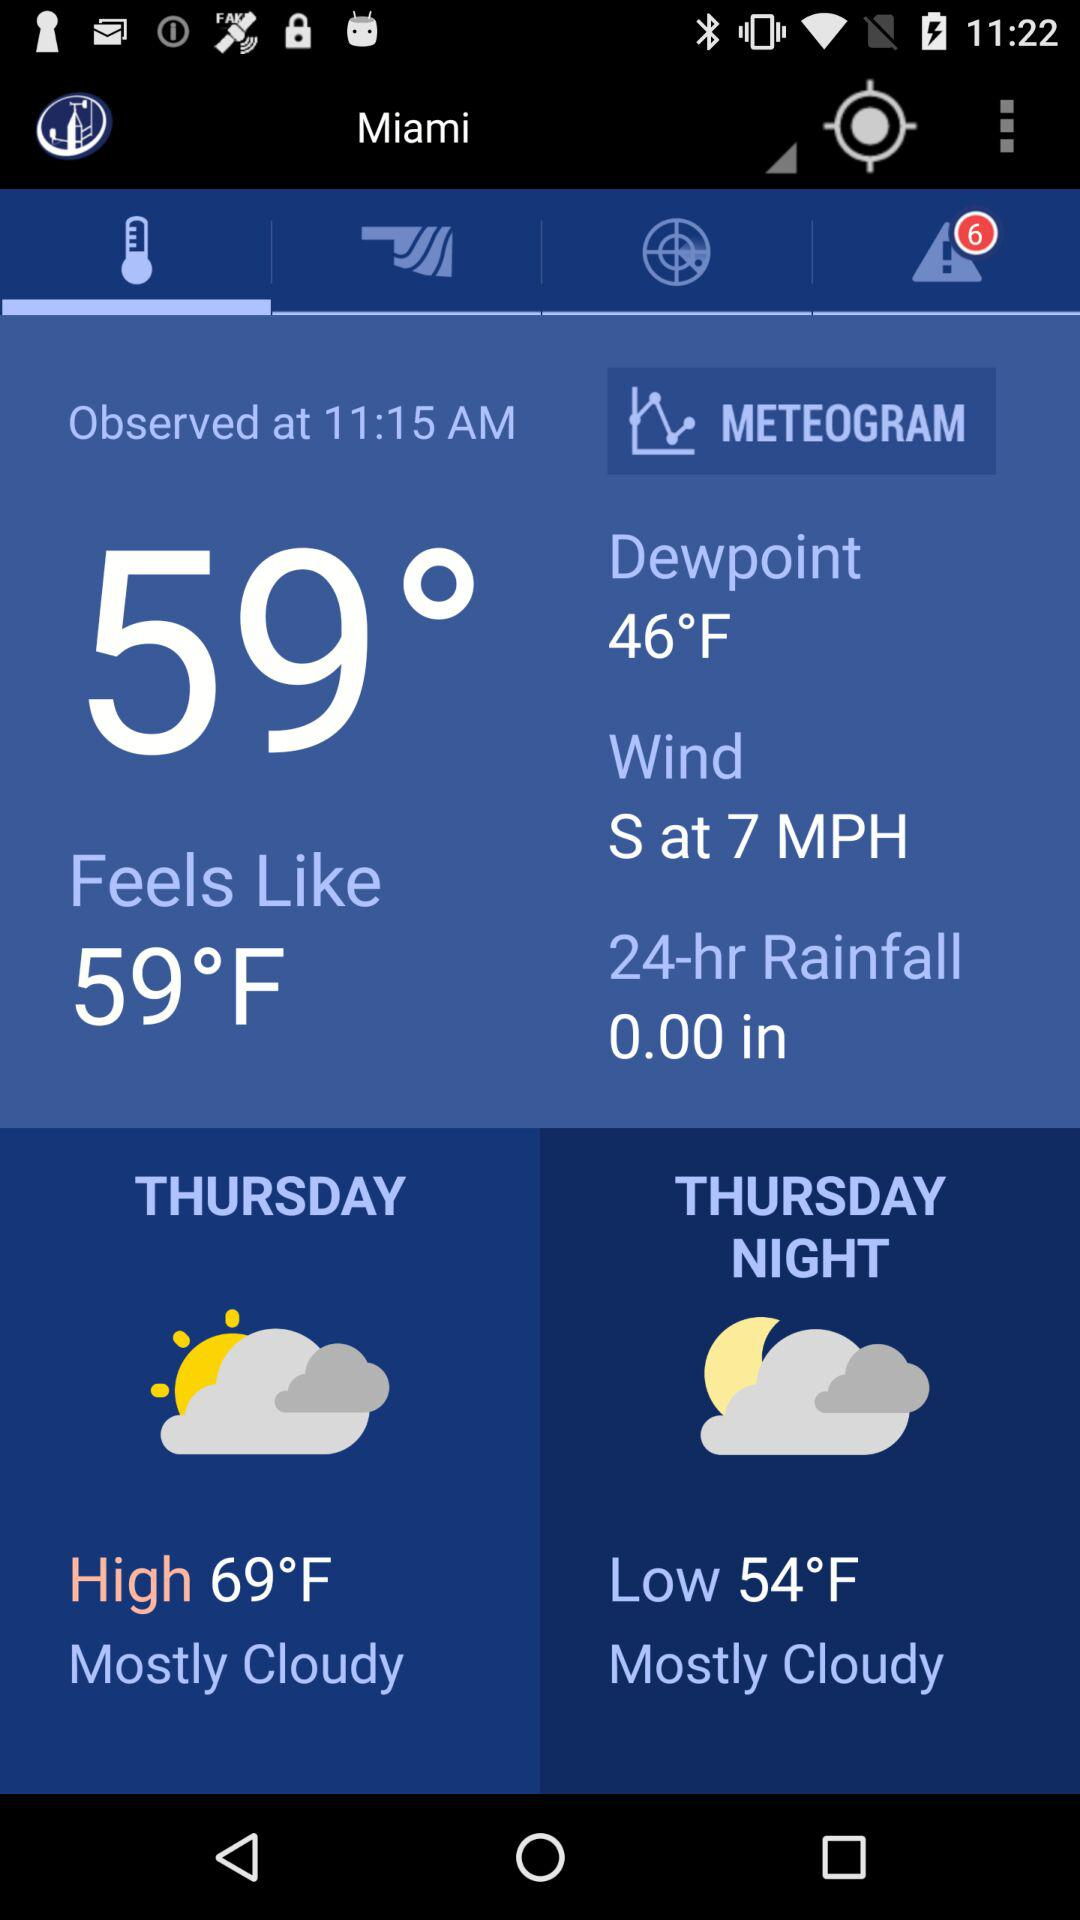What is the weather forecast on Thursday?
When the provided information is insufficient, respond with <no answer>. <no answer> 